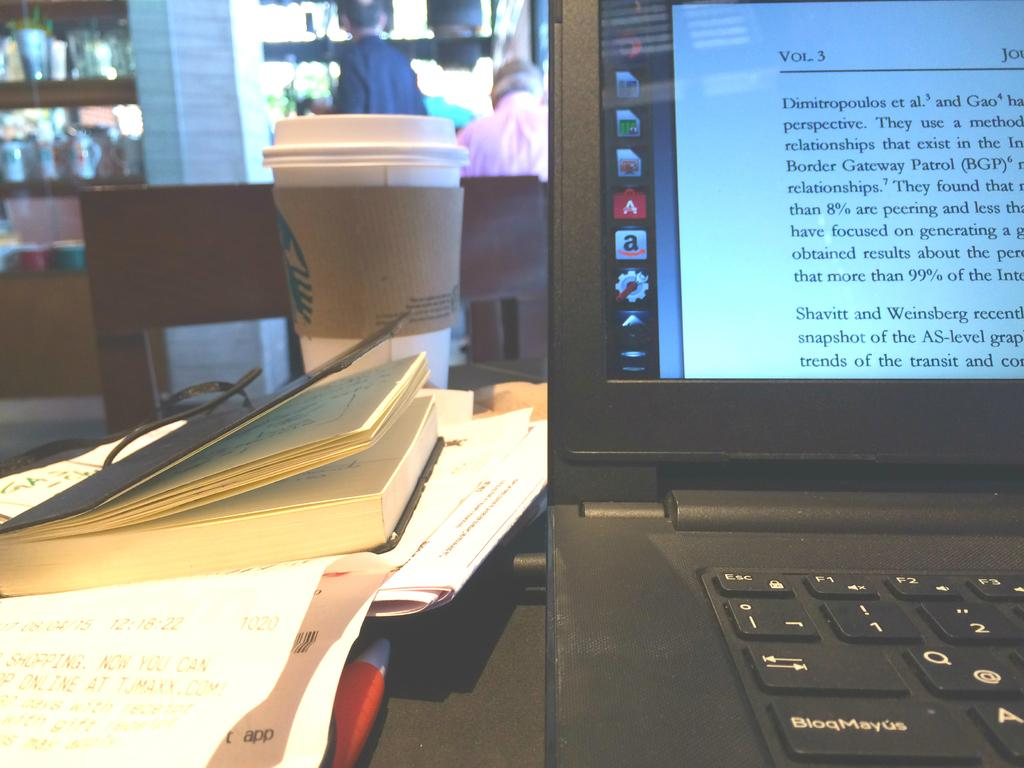Provide a one-sentence caption for the provided image. A laptop at a Starbucks displaying volume 3 on its screen. 